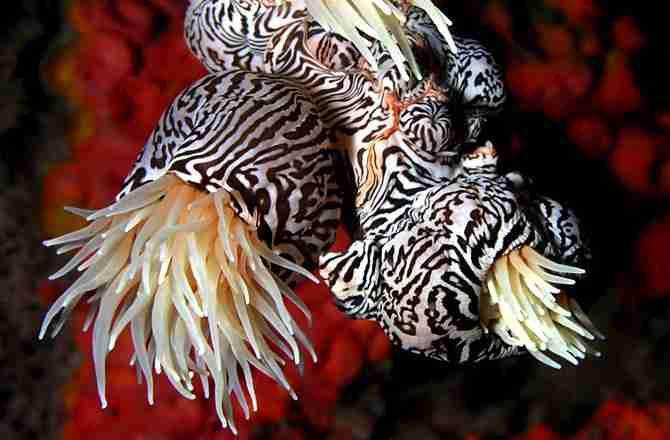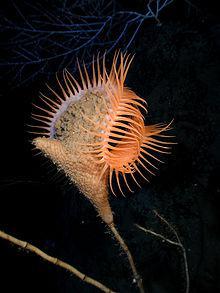The first image is the image on the left, the second image is the image on the right. Assess this claim about the two images: "There are red stones on the sea floor.". Correct or not? Answer yes or no. Yes. 